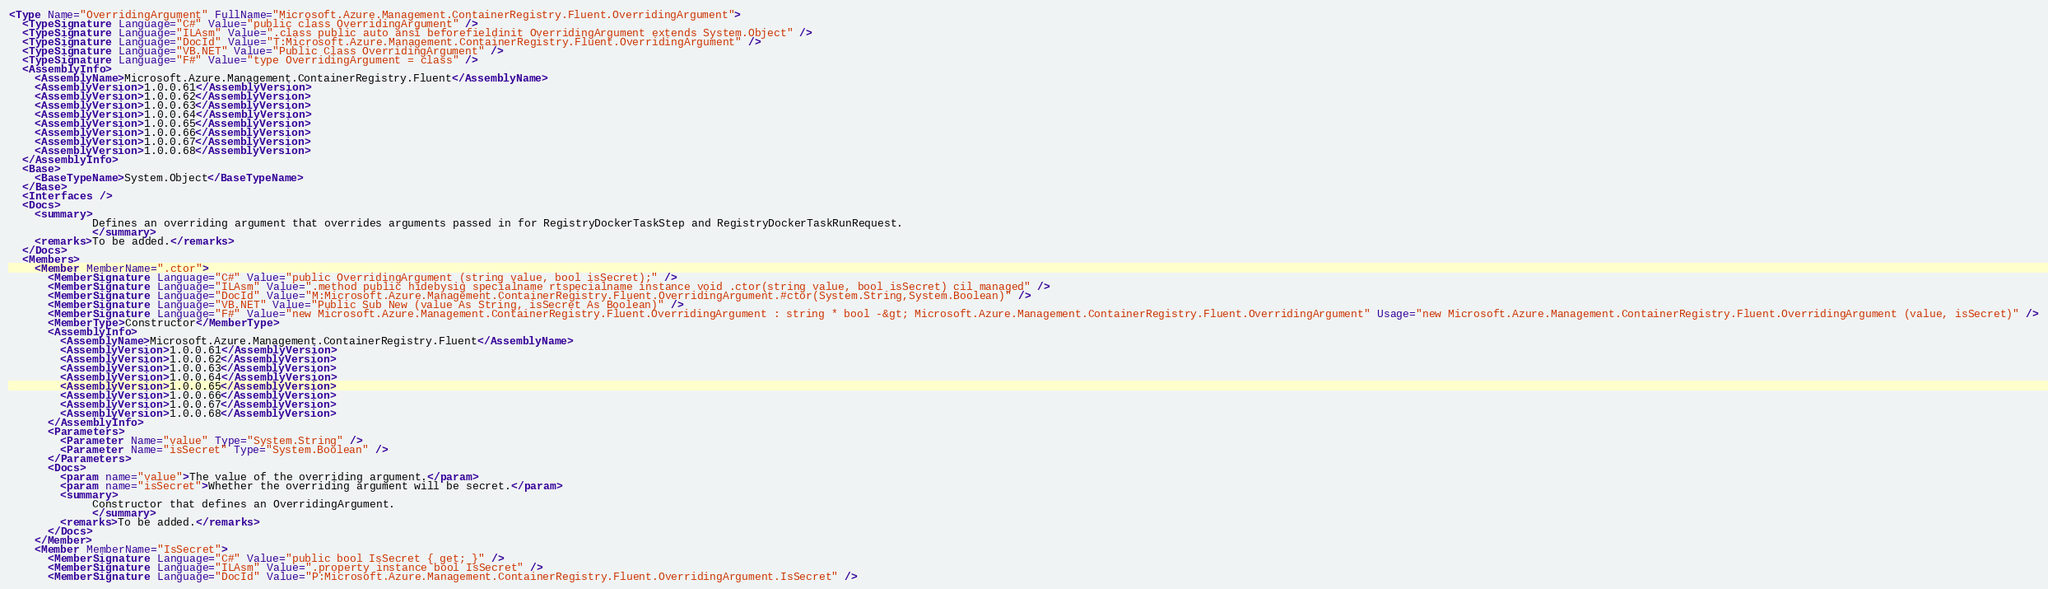Convert code to text. <code><loc_0><loc_0><loc_500><loc_500><_XML_><Type Name="OverridingArgument" FullName="Microsoft.Azure.Management.ContainerRegistry.Fluent.OverridingArgument">
  <TypeSignature Language="C#" Value="public class OverridingArgument" />
  <TypeSignature Language="ILAsm" Value=".class public auto ansi beforefieldinit OverridingArgument extends System.Object" />
  <TypeSignature Language="DocId" Value="T:Microsoft.Azure.Management.ContainerRegistry.Fluent.OverridingArgument" />
  <TypeSignature Language="VB.NET" Value="Public Class OverridingArgument" />
  <TypeSignature Language="F#" Value="type OverridingArgument = class" />
  <AssemblyInfo>
    <AssemblyName>Microsoft.Azure.Management.ContainerRegistry.Fluent</AssemblyName>
    <AssemblyVersion>1.0.0.61</AssemblyVersion>
    <AssemblyVersion>1.0.0.62</AssemblyVersion>
    <AssemblyVersion>1.0.0.63</AssemblyVersion>
    <AssemblyVersion>1.0.0.64</AssemblyVersion>
    <AssemblyVersion>1.0.0.65</AssemblyVersion>
    <AssemblyVersion>1.0.0.66</AssemblyVersion>
    <AssemblyVersion>1.0.0.67</AssemblyVersion>
    <AssemblyVersion>1.0.0.68</AssemblyVersion>
  </AssemblyInfo>
  <Base>
    <BaseTypeName>System.Object</BaseTypeName>
  </Base>
  <Interfaces />
  <Docs>
    <summary>
             Defines an overriding argument that overrides arguments passed in for RegistryDockerTaskStep and RegistryDockerTaskRunRequest.
             </summary>
    <remarks>To be added.</remarks>
  </Docs>
  <Members>
    <Member MemberName=".ctor">
      <MemberSignature Language="C#" Value="public OverridingArgument (string value, bool isSecret);" />
      <MemberSignature Language="ILAsm" Value=".method public hidebysig specialname rtspecialname instance void .ctor(string value, bool isSecret) cil managed" />
      <MemberSignature Language="DocId" Value="M:Microsoft.Azure.Management.ContainerRegistry.Fluent.OverridingArgument.#ctor(System.String,System.Boolean)" />
      <MemberSignature Language="VB.NET" Value="Public Sub New (value As String, isSecret As Boolean)" />
      <MemberSignature Language="F#" Value="new Microsoft.Azure.Management.ContainerRegistry.Fluent.OverridingArgument : string * bool -&gt; Microsoft.Azure.Management.ContainerRegistry.Fluent.OverridingArgument" Usage="new Microsoft.Azure.Management.ContainerRegistry.Fluent.OverridingArgument (value, isSecret)" />
      <MemberType>Constructor</MemberType>
      <AssemblyInfo>
        <AssemblyName>Microsoft.Azure.Management.ContainerRegistry.Fluent</AssemblyName>
        <AssemblyVersion>1.0.0.61</AssemblyVersion>
        <AssemblyVersion>1.0.0.62</AssemblyVersion>
        <AssemblyVersion>1.0.0.63</AssemblyVersion>
        <AssemblyVersion>1.0.0.64</AssemblyVersion>
        <AssemblyVersion>1.0.0.65</AssemblyVersion>
        <AssemblyVersion>1.0.0.66</AssemblyVersion>
        <AssemblyVersion>1.0.0.67</AssemblyVersion>
        <AssemblyVersion>1.0.0.68</AssemblyVersion>
      </AssemblyInfo>
      <Parameters>
        <Parameter Name="value" Type="System.String" />
        <Parameter Name="isSecret" Type="System.Boolean" />
      </Parameters>
      <Docs>
        <param name="value">The value of the overriding argument.</param>
        <param name="isSecret">Whether the overriding argument will be secret.</param>
        <summary>
             Constructor that defines an OverridingArgument.
             </summary>
        <remarks>To be added.</remarks>
      </Docs>
    </Member>
    <Member MemberName="IsSecret">
      <MemberSignature Language="C#" Value="public bool IsSecret { get; }" />
      <MemberSignature Language="ILAsm" Value=".property instance bool IsSecret" />
      <MemberSignature Language="DocId" Value="P:Microsoft.Azure.Management.ContainerRegistry.Fluent.OverridingArgument.IsSecret" /></code> 